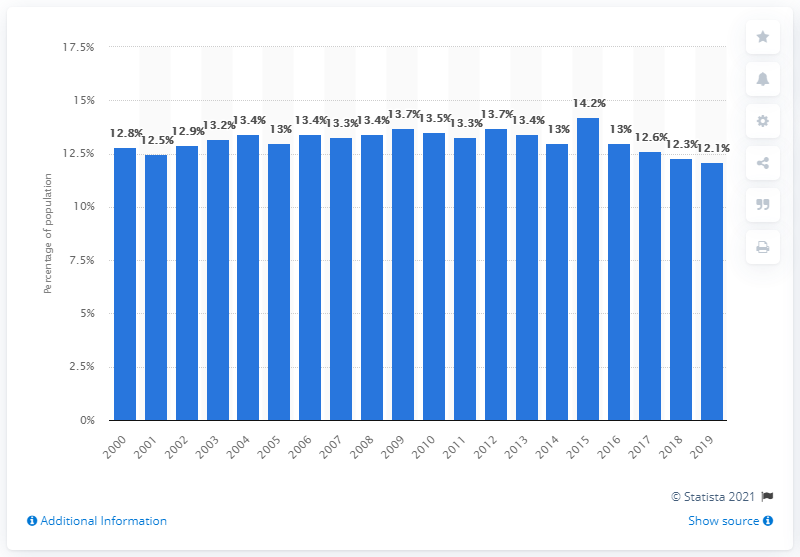Specify some key components in this picture. In 2019, approximately 12.1% of Canadians were living in low income, according to recent data. 